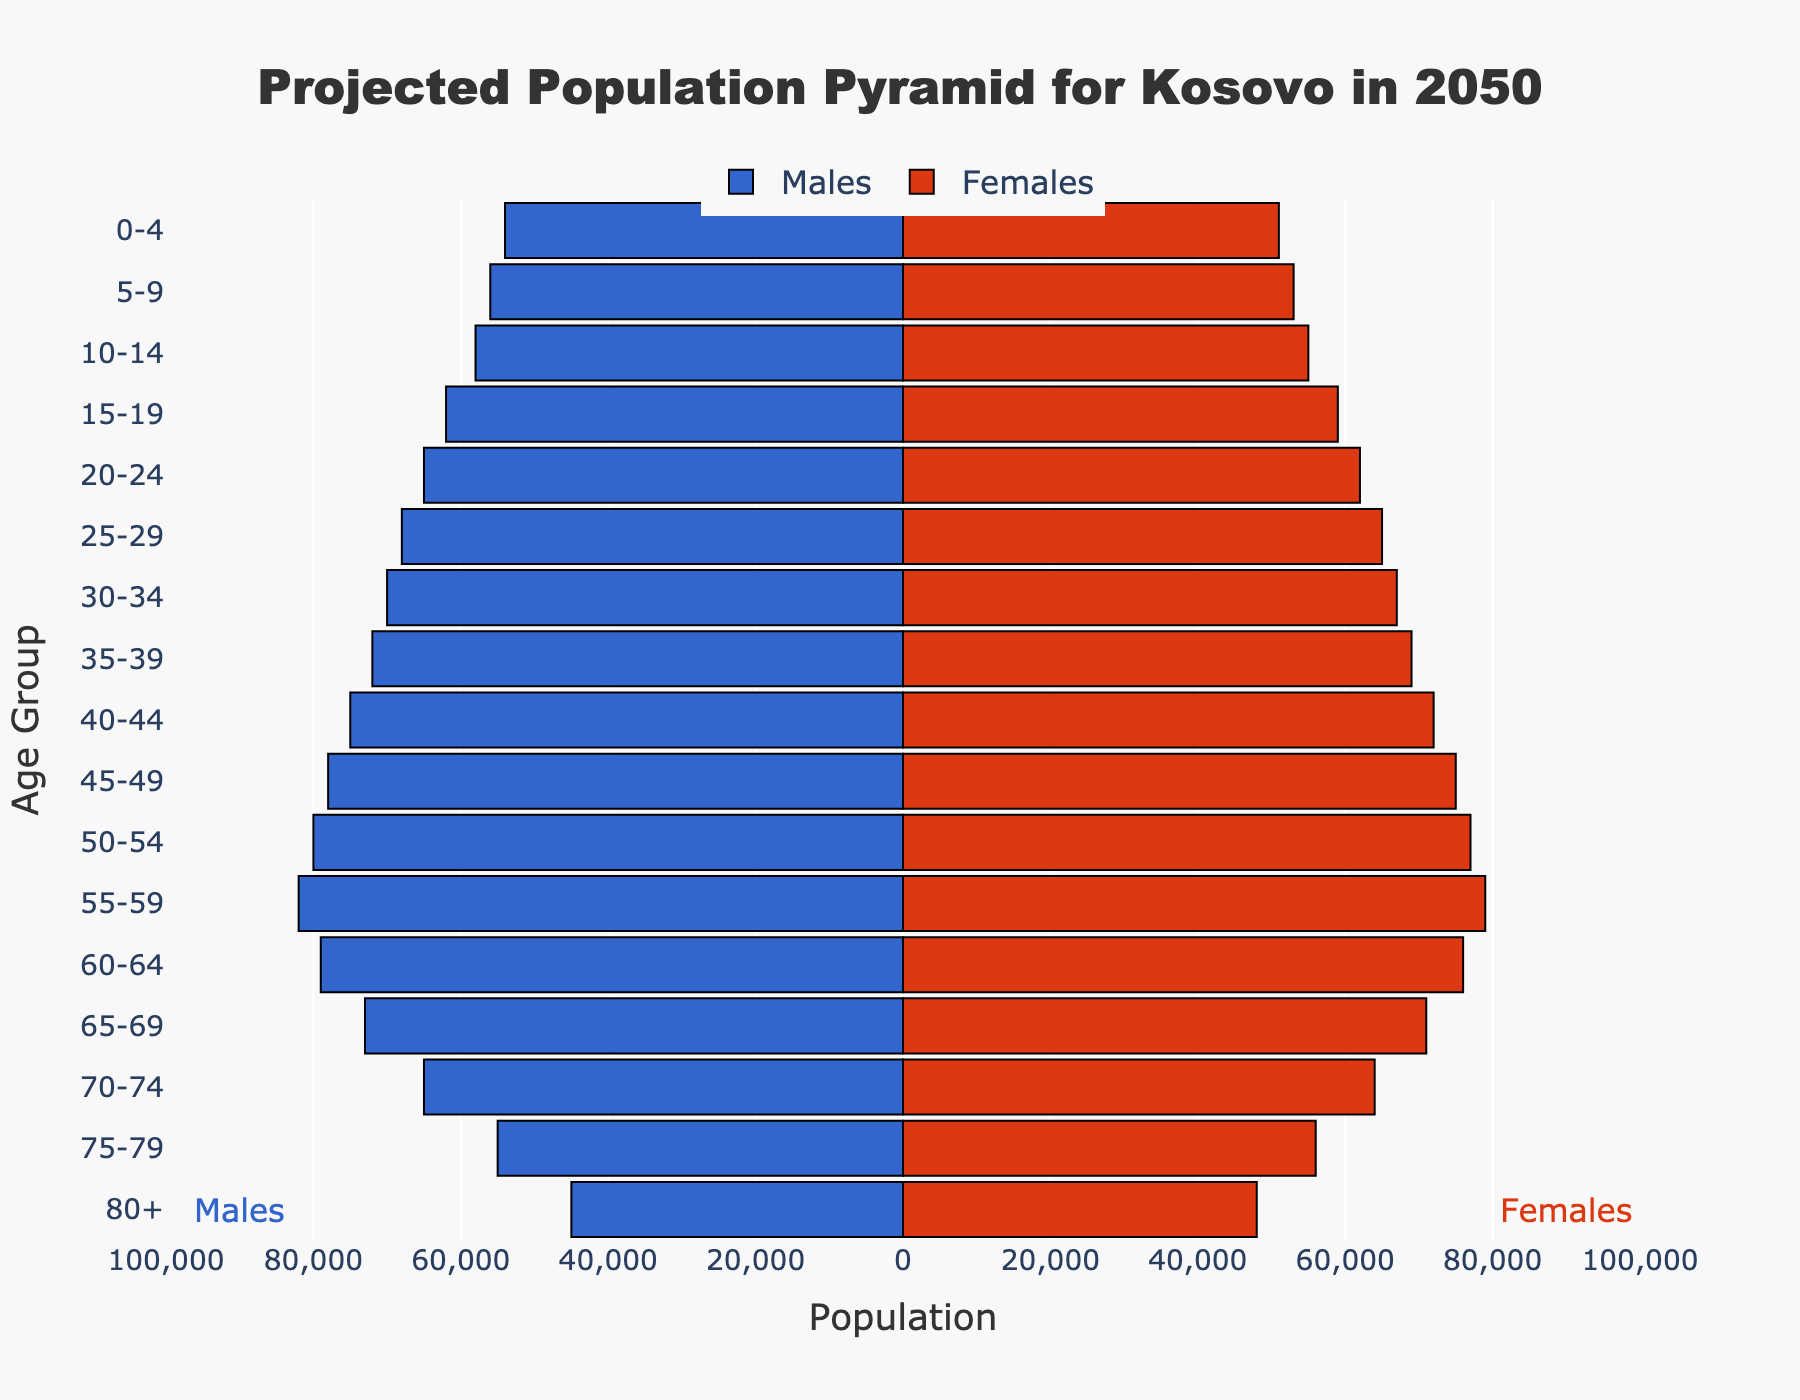What's the title of the figure? The title is displayed prominently at the top of the figure, indicating what the graph represents. The title is "Projected Population Pyramid for Kosovo in 2050"
Answer: Projected Population Pyramid for Kosovo in 2050 Which gender has a larger population in the age group 40-44? The figure uses color to differentiate between males and females. By looking at the bars corresponding to age group 40-44, the length of the red bar (females) is shorter compared to the blue bar (males), indicating fewer females.
Answer: Males What is the population difference between males and females in the age group 25-29? To find the difference, subtract the female population (65,000) from the male population (68,000) for age group 25-29. 68,000 - 65,000 = 3,000
Answer: 3,000 In which age group is the female population higher than the male population? By examining the lengths of the bars for each age group, we see that the red bar is longer than the blue bar in the age group 75-79, indicating a higher female population.
Answer: 75-79 How does the population of males change from age group 0-4 to 5-9? Examine the lengths of the bars for males in age groups 0-4 and 5-9. The population increases from 54,000 to 56,000. The change is found by subtracting 54,000 from 56,000, resulting in an increase of 2,000.
Answer: Increases by 2,000 What is the total population of males and females in the age group 70-74? Add the male and female populations in the 70-74 age group. Males are 65,000 and females are 64,000. 65,000 + 64,000 = 129,000
Answer: 129,000 Which age group has the smallest population for both males and females combined? By summing the populations of males and females in each age group and comparing them, the group 80+ has the smallest combined population (45,000 males + 48,000 females = 93,000).
Answer: 80+ What is the difference between the total female population in age groups 50-54 and 55-59? Subtract the female population in age group 55-59 (79,000) from the female population in age group 50-54 (77,000). 77,000 - 79,000 = -2,000 (a decrease of 2,000).
Answer: -2,000 